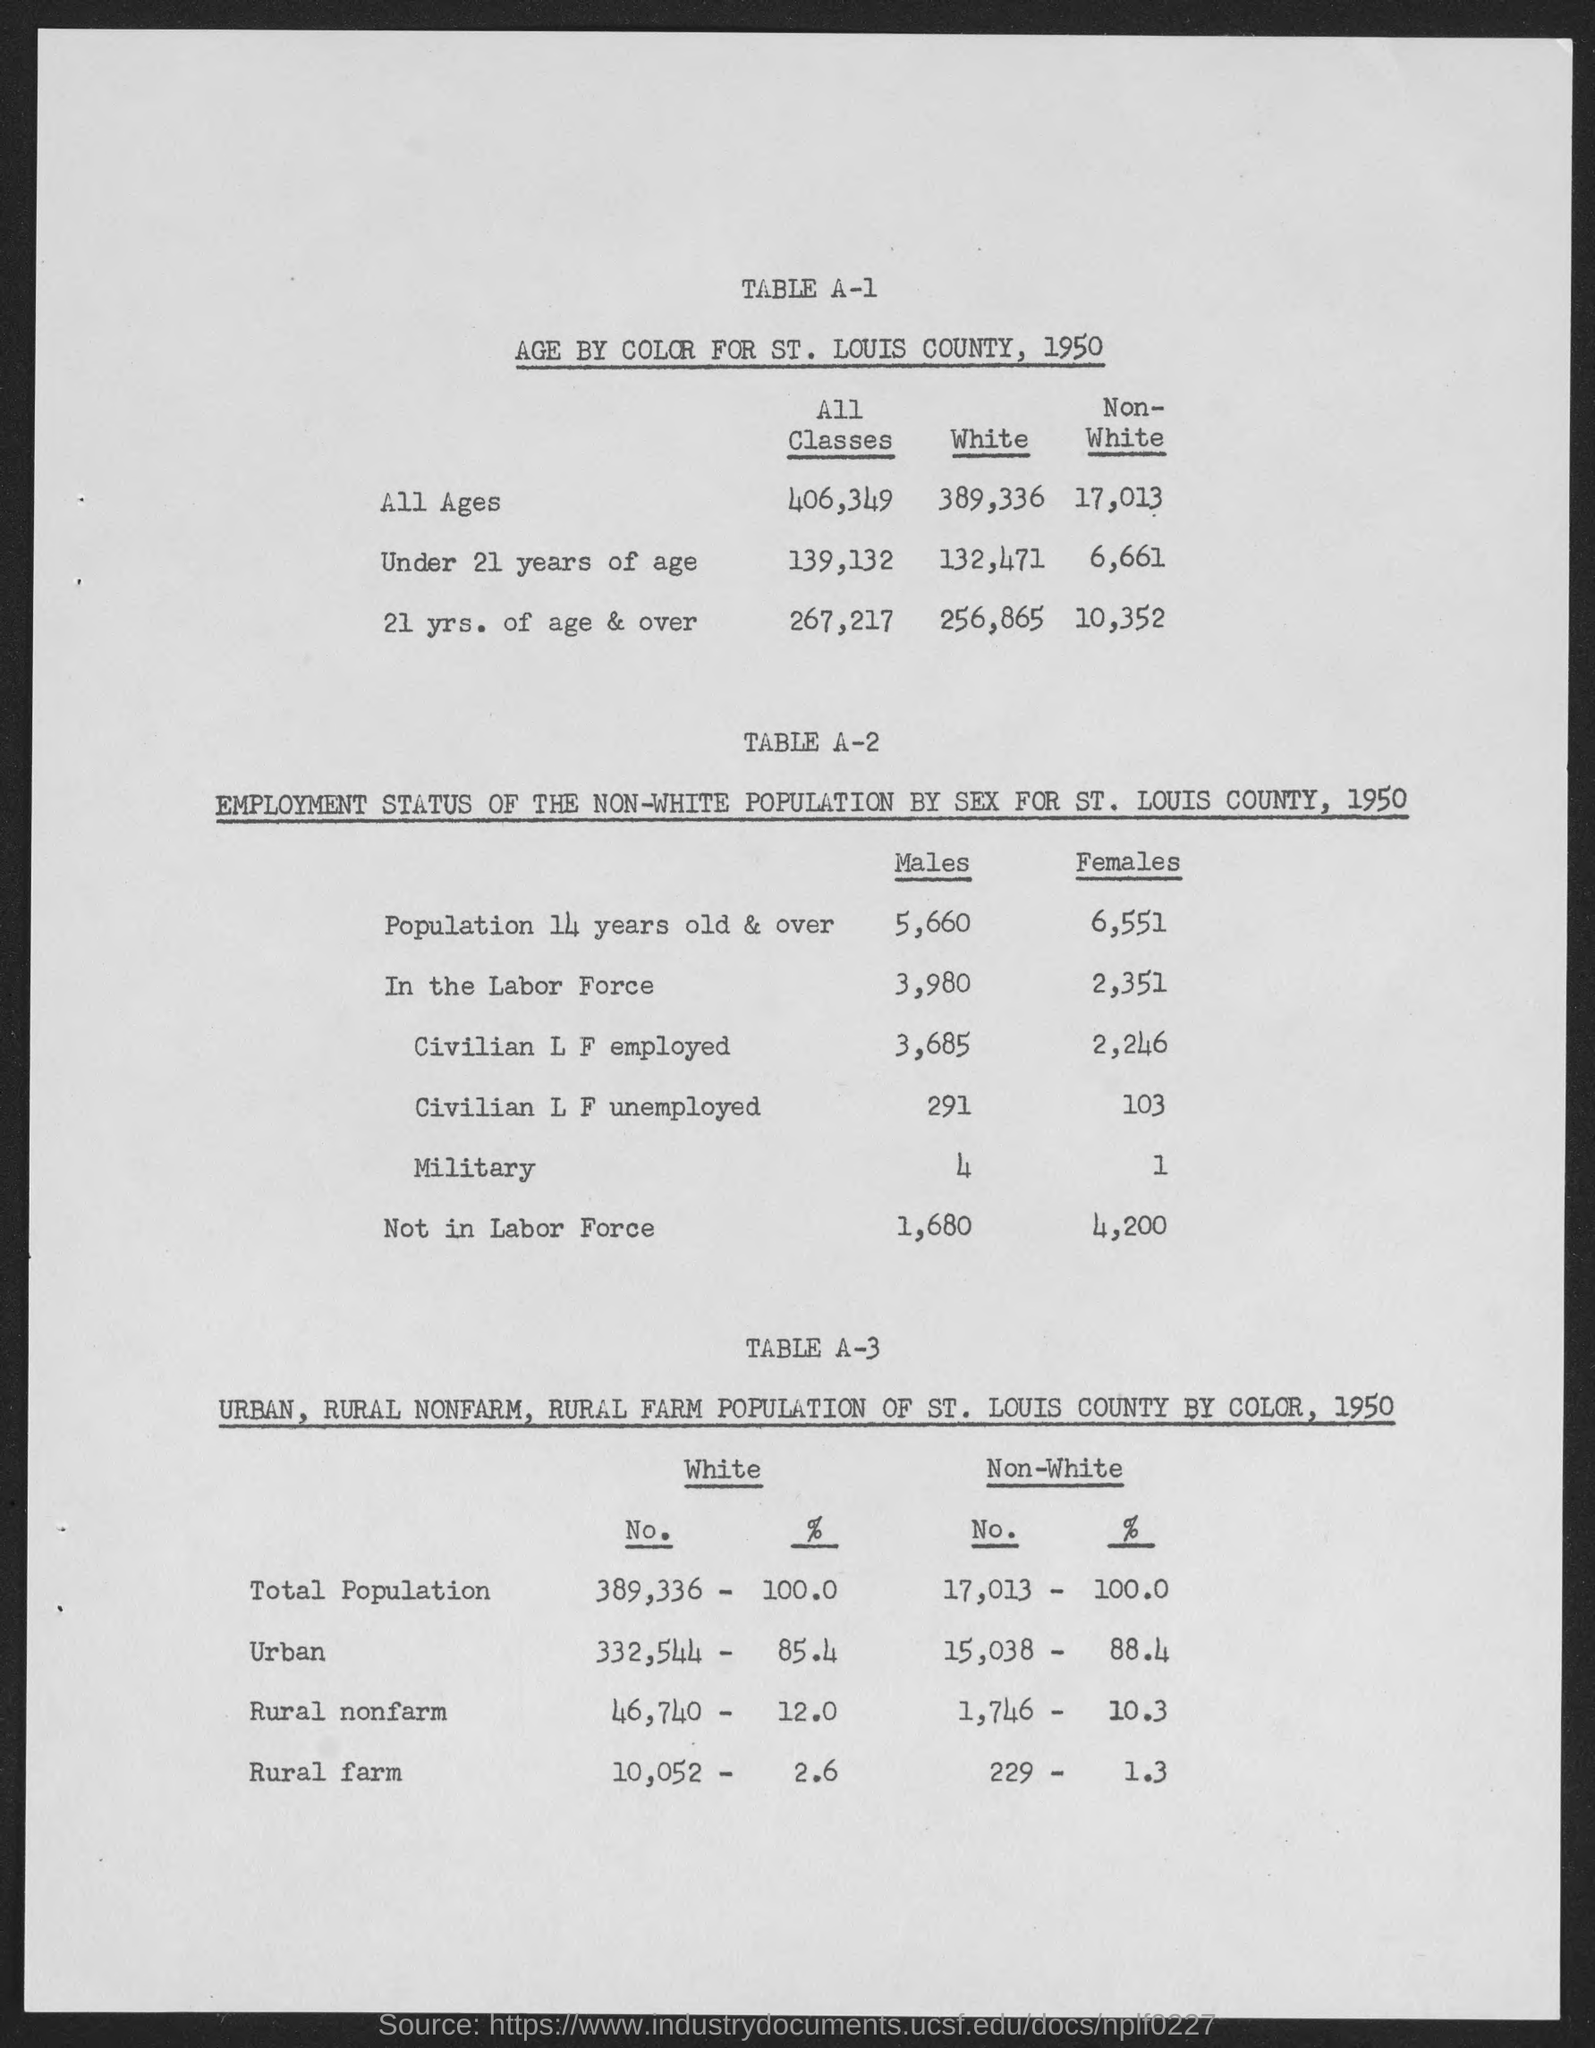What were the employment figures for non-white males in the labor force in St. Louis County in 1950? In 1950, there were 3,980 non-white males in the labor force in St. Louis County, with 3,685 being employed and 291 unemployed. 